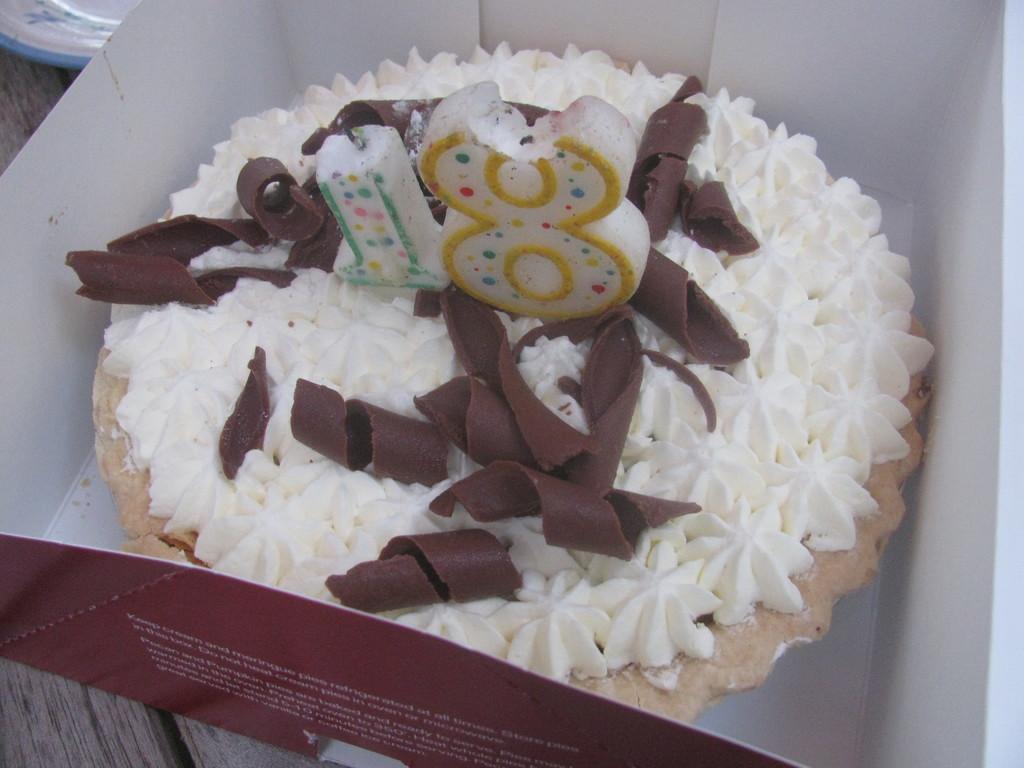How would you summarize this image in a sentence or two? In this image, we can see a table, on the table, we can see a box. In the box, we can see a cake and a candle. In the left corner of the table, we can see one edge of a plate. 